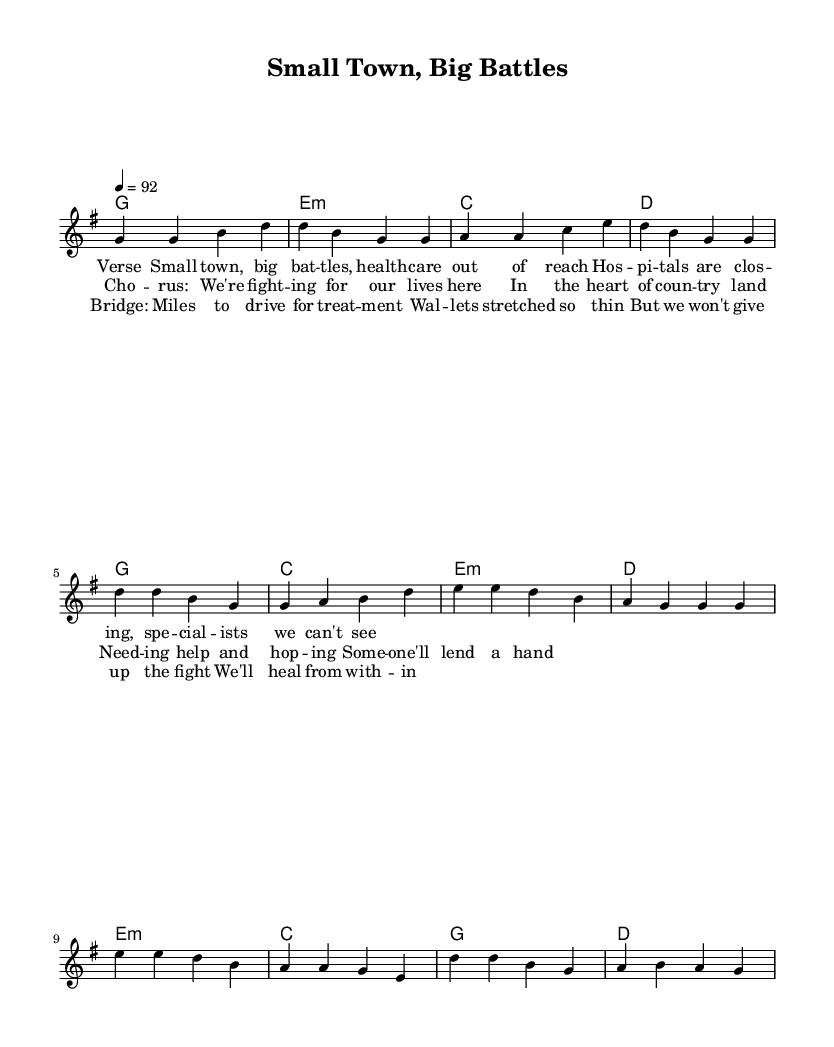What is the key signature of this music? The key signature is G major, which has one sharp (F#). This can be identified at the beginning of the sheet music under the clef sign.
Answer: G major What is the time signature of this music? The time signature is 4/4, as indicated at the beginning of the score. It means there are four beats in each measure and the quarter note gets one beat.
Answer: 4/4 What is the tempo marking for this piece? The tempo marking is 92 beats per minute, specified in the score as "4 = 92." This indicates how fast the music should be played.
Answer: 92 How many verses are present in the song structure? There is one verse explicitly shown in the lyrics section of the sheet music. The song structure only includes one set of lyrics labeled as "Verse 1."
Answer: One What is a primary theme expressed in the chorus? The primary theme in the chorus discusses the struggle for health care and assistance in rural areas, emphasizing a plea for help. This is indicated through the lyrics provided.
Answer: Health care struggle How does the melody change in the bridge section compared to the verse? In the bridge, the melody features a slight rise and fall in pitch with some different notes than the verse, indicating a different emotional tone and transition in theme from the verses, as seen directly in the sheet music.
Answer: Different notes What is the chord progression for the chorus? The chord progression for the chorus is G, C, E minor, D. This can be located in the harmonies section, where the chords are explicitly written above the melody.
Answer: G, C, E minor, D 